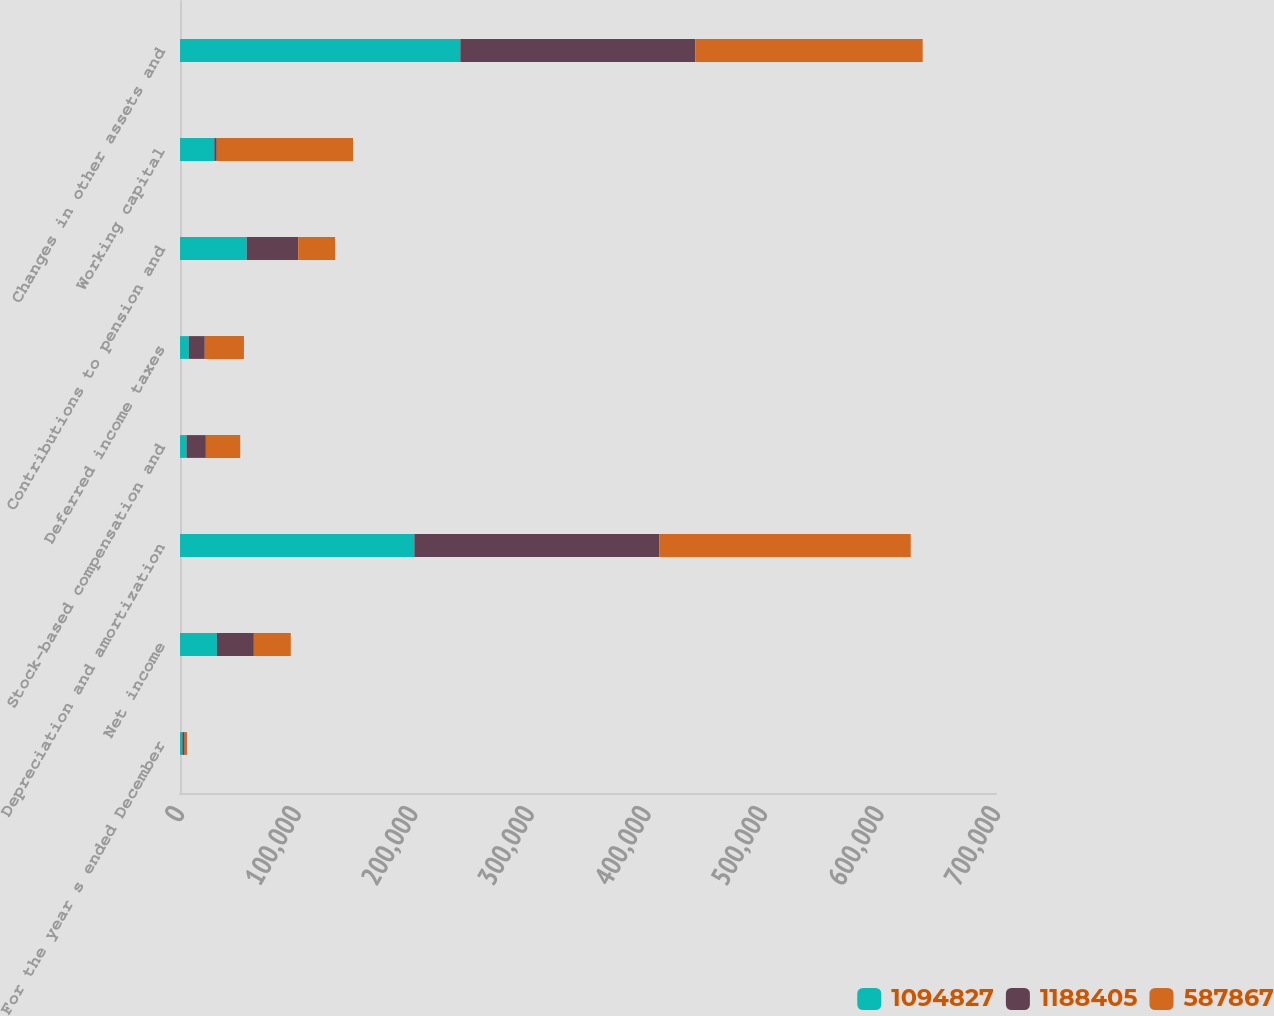<chart> <loc_0><loc_0><loc_500><loc_500><stacked_bar_chart><ecel><fcel>For the year s ended December<fcel>Net income<fcel>Depreciation and amortization<fcel>Stock-based compensation and<fcel>Deferred income taxes<fcel>Contributions to pension and<fcel>Working capital<fcel>Changes in other assets and<nl><fcel>1.09483e+06<fcel>2013<fcel>31671<fcel>201033<fcel>5571<fcel>7457<fcel>57213<fcel>29391<fcel>240478<nl><fcel>1.1884e+06<fcel>2012<fcel>31671<fcel>210037<fcel>16606<fcel>13785<fcel>44208<fcel>2133<fcel>201665<nl><fcel>587867<fcel>2011<fcel>31671<fcel>215763<fcel>29471<fcel>33611<fcel>31671<fcel>116909<fcel>194948<nl></chart> 